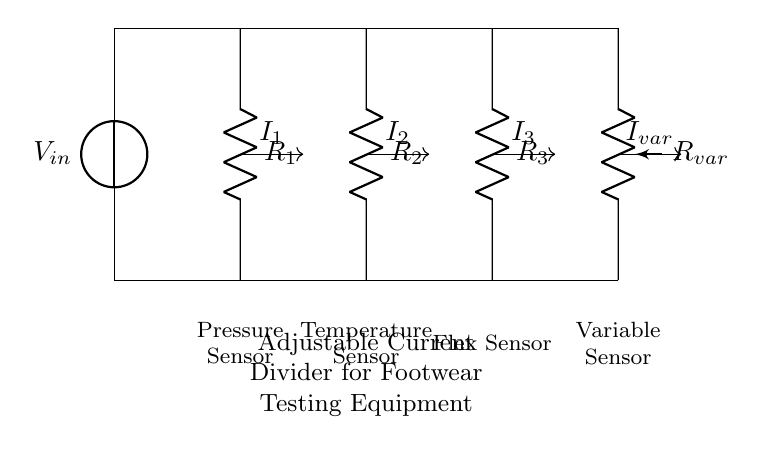What is the input voltage? The input voltage, denoted as Vin, is typically represented in volts (V), but the specific value is not provided in the diagram.
Answer: Vin How many resistors are in the circuit? The circuit contains three resistors: R1, R2, and R3, in addition to an adjustable potentiometer.
Answer: Four What components regulate the current to the sensors? The current to the sensors is regulated by the resistors R1, R2, R3, and the variable resistor Rvar which allows for adjustments in current distribution.
Answer: R1, R2, R3, Rvar What type of sensors are powered by this circuit? The circuit powers a pressure sensor, a temperature sensor, a flex sensor, and a variable sensor, which indicate its application in footwear testing.
Answer: Pressure, temperature, flex, variable Which component allows for current adjustment? The adjustable potentiometer, labeled as Rvar, allows for current adjustment to the sensors by changing its resistance.
Answer: Rvar If R1 is 100 ohms, R2 is 200 ohms, and R3 is 300 ohms, what is the current through R2 if the total current is 10 milliamps? To find the current through R2, use the current divider formula: I2 = I_total * (R_total / R2). The total resistance (R_total) is the sum of the resistors in parallel. The current through R2 can be calculated as 10mA * (100 + 200)/(200). Therefore, I2 = 4 milliamps.
Answer: 4 milliamps 